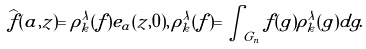<formula> <loc_0><loc_0><loc_500><loc_500>\widehat { f } ( a , z ) = \rho _ { k } ^ { \lambda } ( f ) e _ { a } ( z , 0 ) , \, \rho _ { k } ^ { \lambda } ( f ) = \int _ { G _ { n } } f ( g ) \rho _ { k } ^ { \lambda } ( g ) d g .</formula> 